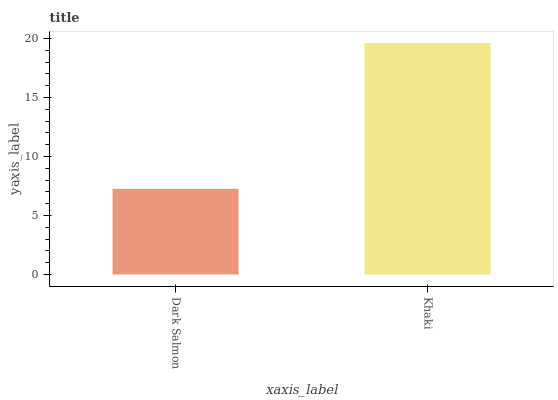Is Dark Salmon the minimum?
Answer yes or no. Yes. Is Khaki the maximum?
Answer yes or no. Yes. Is Khaki the minimum?
Answer yes or no. No. Is Khaki greater than Dark Salmon?
Answer yes or no. Yes. Is Dark Salmon less than Khaki?
Answer yes or no. Yes. Is Dark Salmon greater than Khaki?
Answer yes or no. No. Is Khaki less than Dark Salmon?
Answer yes or no. No. Is Khaki the high median?
Answer yes or no. Yes. Is Dark Salmon the low median?
Answer yes or no. Yes. Is Dark Salmon the high median?
Answer yes or no. No. Is Khaki the low median?
Answer yes or no. No. 